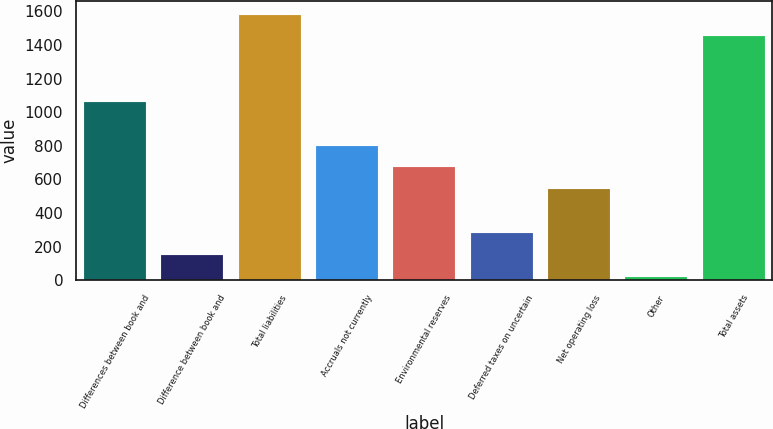Convert chart to OTSL. <chart><loc_0><loc_0><loc_500><loc_500><bar_chart><fcel>Differences between book and<fcel>Difference between book and<fcel>Total liabilities<fcel>Accruals not currently<fcel>Environmental reserves<fcel>Deferred taxes on uncertain<fcel>Net operating loss<fcel>Other<fcel>Total assets<nl><fcel>1061.08<fcel>151.71<fcel>1580.72<fcel>801.26<fcel>671.35<fcel>281.62<fcel>541.44<fcel>21.8<fcel>1450.81<nl></chart> 